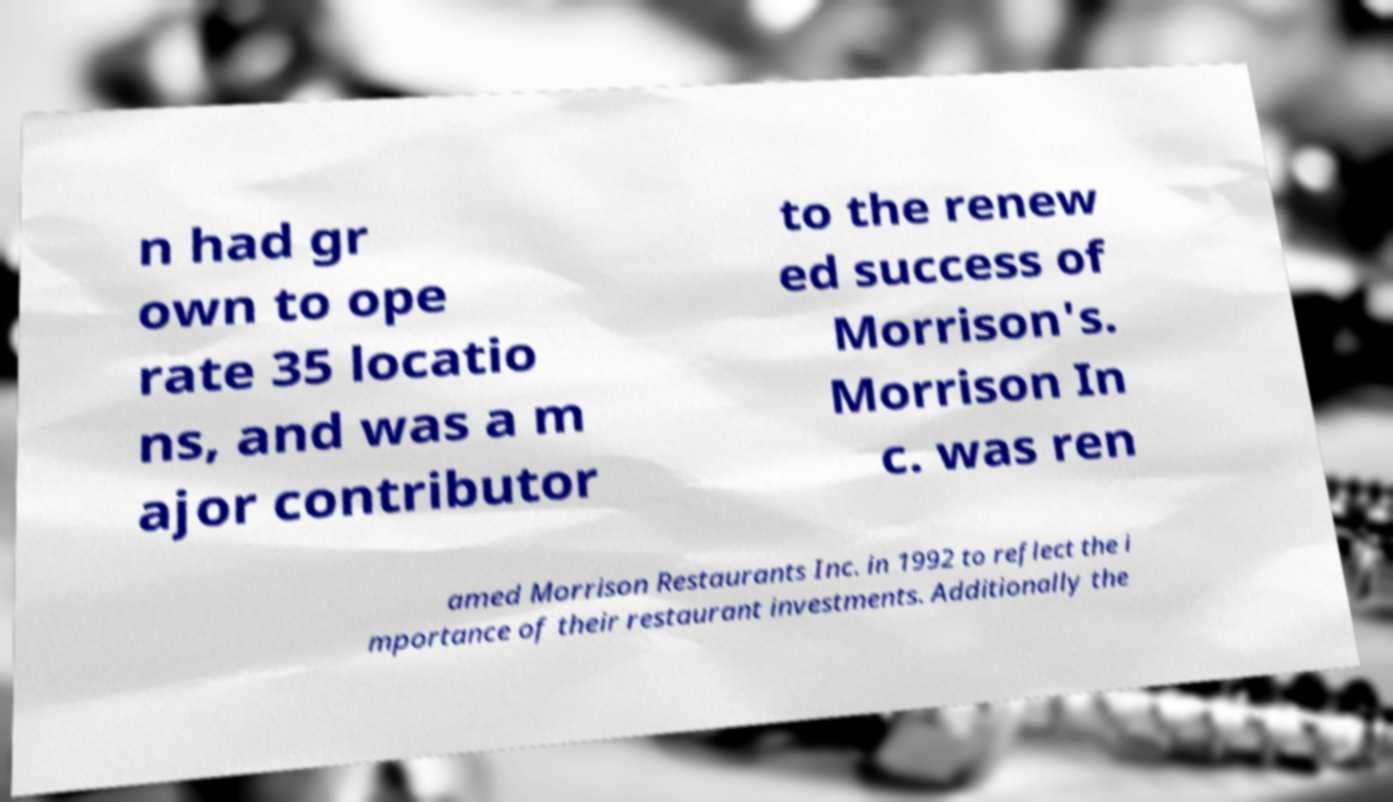Please identify and transcribe the text found in this image. n had gr own to ope rate 35 locatio ns, and was a m ajor contributor to the renew ed success of Morrison's. Morrison In c. was ren amed Morrison Restaurants Inc. in 1992 to reflect the i mportance of their restaurant investments. Additionally the 